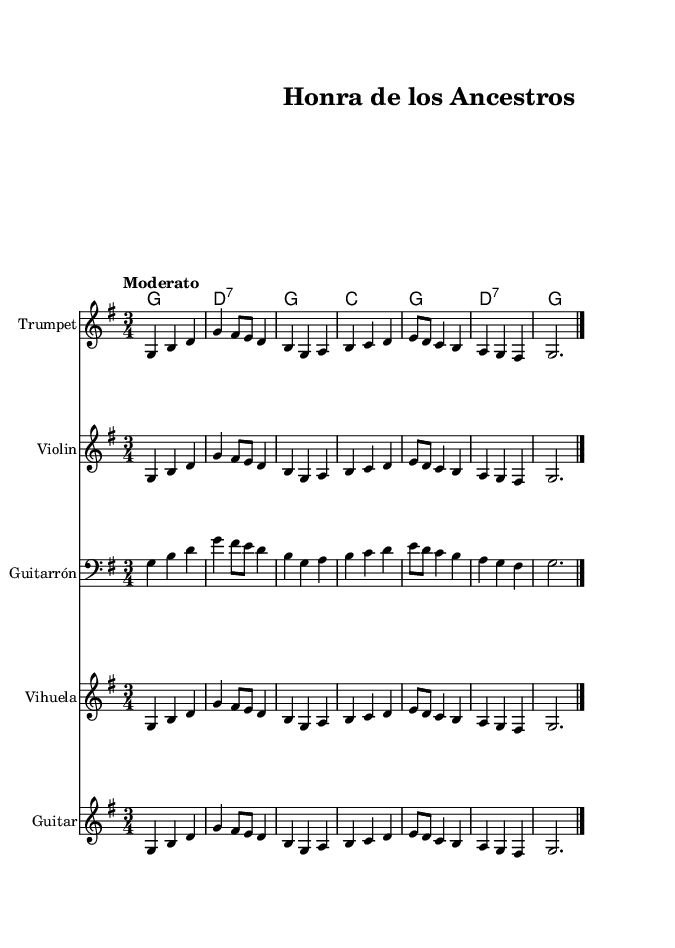What is the key signature of this music? The key signature has one sharp (F#) indicated in the staff. This means it is in the key of G major.
Answer: G major What is the time signature of this music? The time signature is indicated at the beginning of the piece, showing 3 beats per measure, which is typical in waltz-like compositions.
Answer: 3/4 What is the tempo marking of this piece? The tempo is noted as "Moderato," which typically suggests a moderately and comfortably fast speed.
Answer: Moderato How many instruments are represented in the score? The score includes five individual staves, clearly labeled for the different instruments: Trumpet, Violin, Guitarrón, Vihuela, and Guitar.
Answer: Five What is the primary theme expressed in the lyrics? The lyrics describe honoring ancestors and remembering their hard work, which is a common theme in traditional mariachi songs.
Answer: Hard work and honor Which chord occurs most frequently in the harmonies? The G major chord occurs consistently throughout the piece, appearing repeatedly in various measures.
Answer: G major What is the musical form of this piece? The structure encompasses a simple combination of melody and lyrics without complex variations, characteristic of many traditional songs, which tends to follow strophic form.
Answer: Strophic 